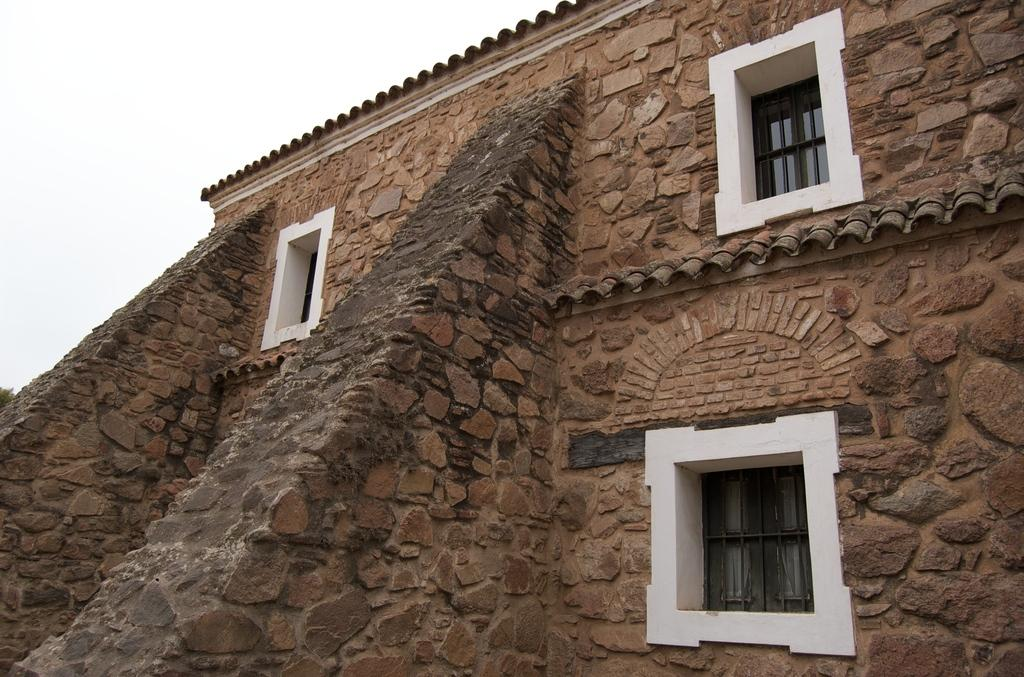What type of structure is visible in the image? There is a wall in the image. What feature allows light to enter the space in the image? There are windows in the image. What can be seen in the distance in the image? The sky is visible in the background of the image. Who is the creator of the watch in the image? There is no watch present in the image. What type of range can be seen in the image? There is no range present in the image. 